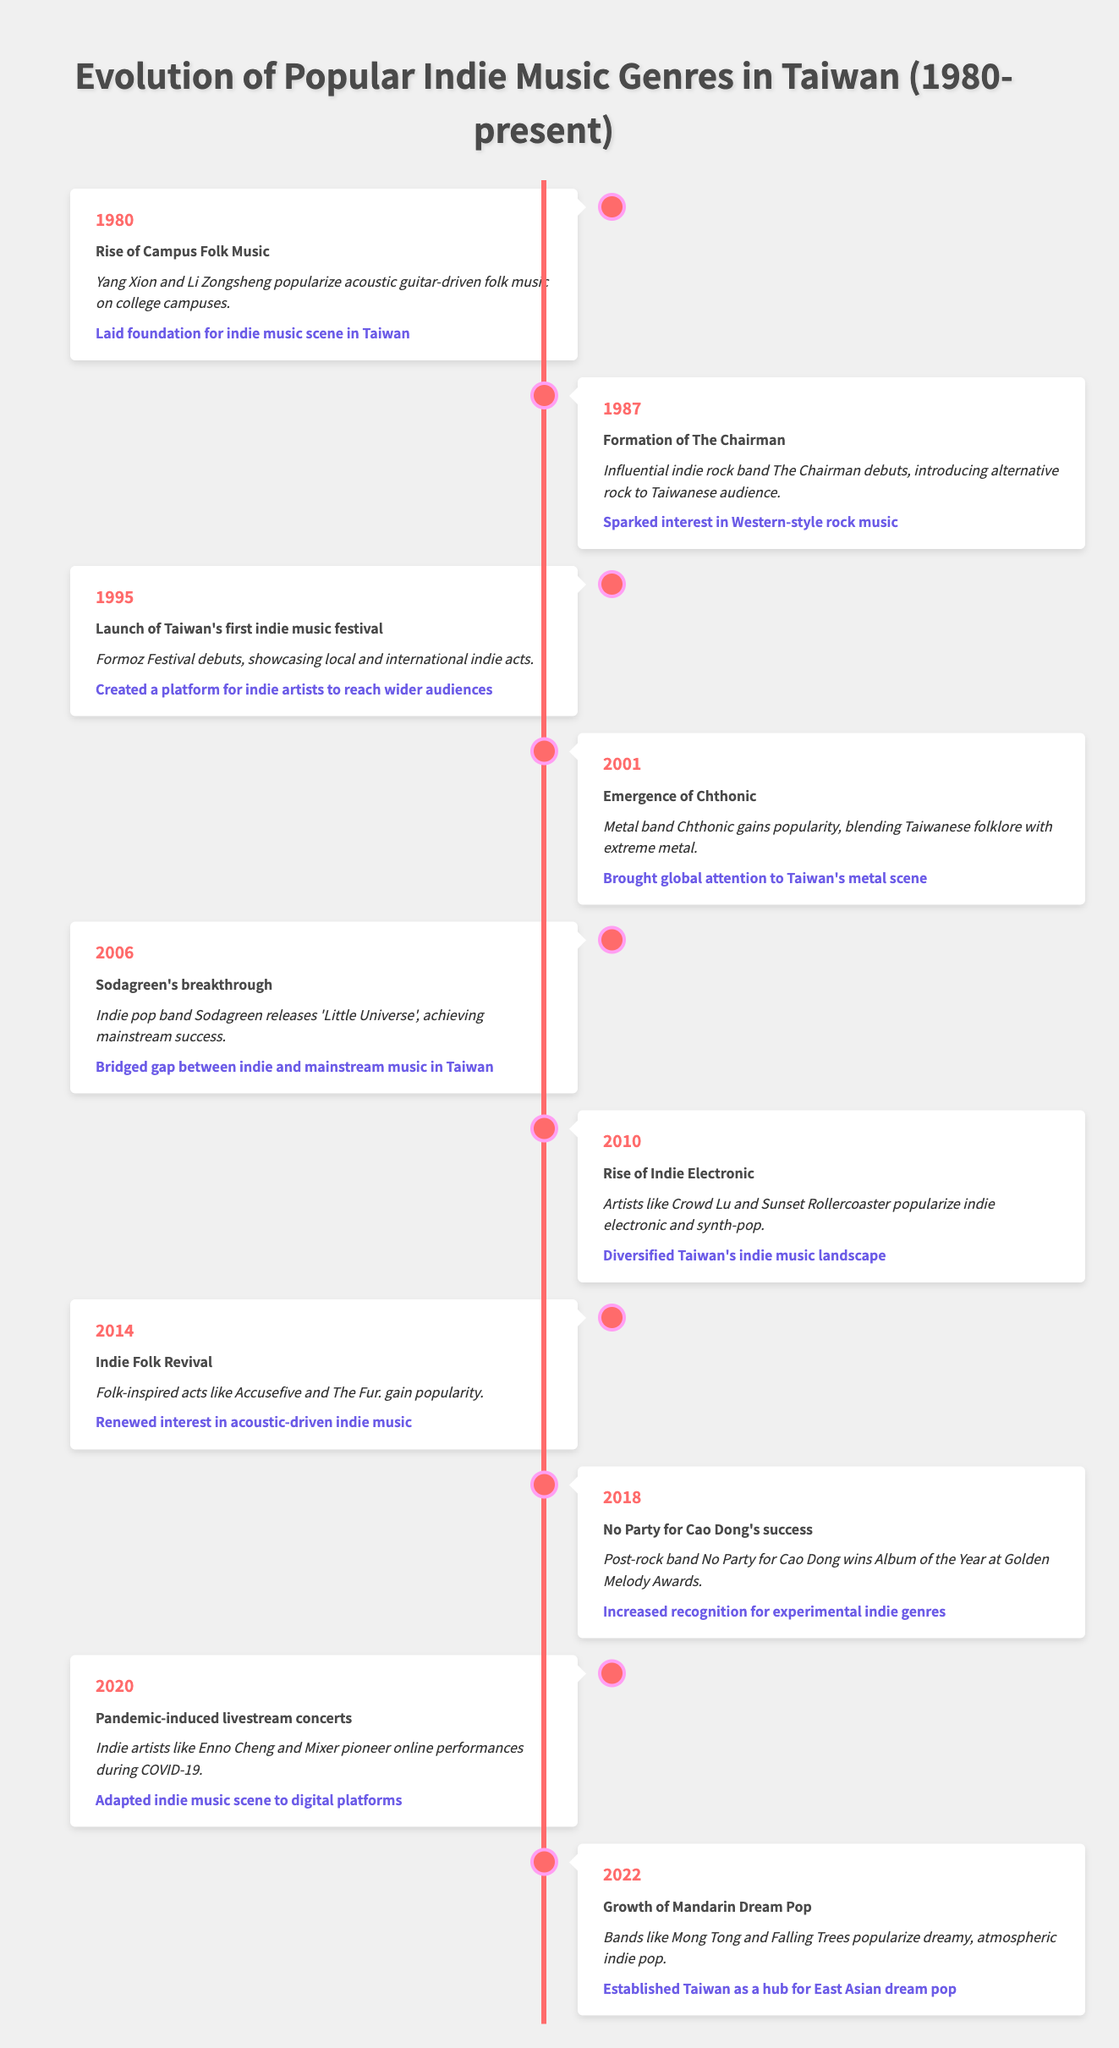What event marked the beginning of the indie music scene in Taiwan? The event that marked the beginning of the indie music scene in Taiwan is the "Rise of Campus Folk Music" in 1980, where Yang Xion and Li Zongsheng popularized acoustic guitar-driven folk music on college campuses.
Answer: Rise of Campus Folk Music What was the impact of the Formation of The Chairman in 1987? The impact of the Formation of The Chairman in 1987 was that it sparked interest in Western-style rock music among Taiwanese audiences, introducing alternative rock to them.
Answer: Sparked interest in Western-style rock music How many years apart were the launch of Taiwan's first indie music festival and the emergence of Chthonic? Taiwan's first indie music festival launched in 1995 and the emergence of Chthonic occurred in 2001. The difference in years is 2001 - 1995 = 6 years.
Answer: 6 years Did Sodagreen's breakthrough contribute to bridging the gap between indie and mainstream music in Taiwan? Yes, Sodagreen's breakthrough with the release of 'Little Universe' in 2006 led to achieving mainstream success, bridging the gap between indie and mainstream music.
Answer: Yes Which event in 2018 increased recognition for experimental indie genres in Taiwan? The event that increased recognition for experimental indie genres in 2018 was No Party for Cao Dong winning Album of the Year at the Golden Melody Awards.
Answer: No Party for Cao Dong's success In which year did the rise of indie electronic music occur, and what was the impact? The rise of indie electronic music occurred in 2010, with artists like Crowd Lu and Sunset Rollercoaster popularizing the genre, thereby diversifying Taiwan's indie music landscape.
Answer: 2010; Diversified Taiwan's indie music landscape What percentage of events listed are related to folk music, considering the total number of events? There are two events related to folk music: the "Rise of Campus Folk Music" in 1980 and "Indie Folk Revival" in 2014 out of a total of ten events. The percentage is (2/10) * 100 = 20%.
Answer: 20% When did the pandemic-induced livestream concerts occur, and what was the adaptation? The pandemic-induced livestream concerts occurred in 2020, where independent artists like Enno Cheng and Mixer pioneered online performances during COVID-19, adapting the indie music scene to digital platforms.
Answer: 2020; Adapted indie music scene to digital platforms In terms of genre diversification, which event was pivotal in Taiwan's indie music scene and why? The pivotal event in terms of genre diversification was the rise of indie electronic music in 2010, as it introduced artists like Crowd Lu and Sunset Rollercoaster, significantly broadening the genre landscape in Taiwan.
Answer: Rise of Indie Electronic in 2010 What significant change took place in Taiwan's music scene starting from 2022? Starting from 2022, the significant change in Taiwan's music scene was the growth of Mandarin Dream Pop, with bands like Mong Tong and Falling Trees popularizing dreamy and atmospheric indie pop, establishing Taiwan as a hub for East Asian dream pop.
Answer: Growth of Mandarin Dream Pop 